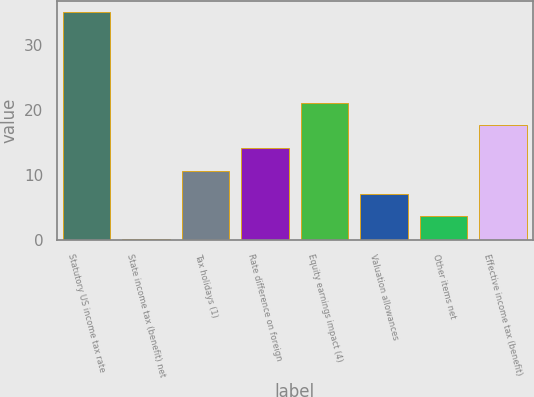Convert chart to OTSL. <chart><loc_0><loc_0><loc_500><loc_500><bar_chart><fcel>Statutory US income tax rate<fcel>State income tax (benefit) net<fcel>Tax holidays (1)<fcel>Rate difference on foreign<fcel>Equity earnings impact (4)<fcel>Valuation allowances<fcel>Other items net<fcel>Effective income tax (benefit)<nl><fcel>35<fcel>0.1<fcel>10.57<fcel>14.06<fcel>21.04<fcel>7.08<fcel>3.59<fcel>17.55<nl></chart> 